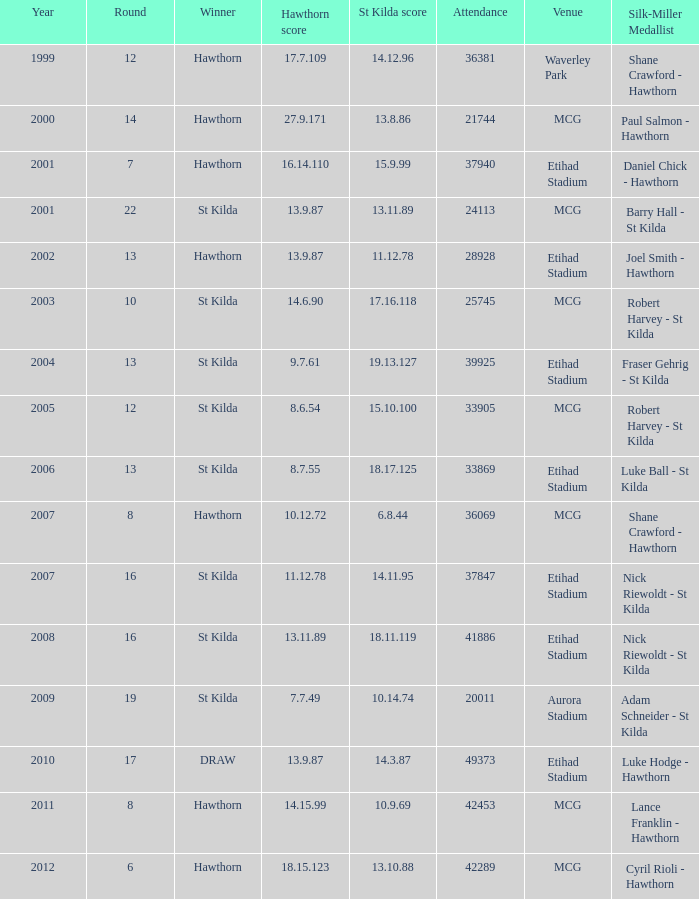What is the hawthorn score at the year 2000? 279171.0. 